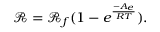Convert formula to latex. <formula><loc_0><loc_0><loc_500><loc_500>\mathcal { R } = \mathcal { R } _ { f } ( 1 - e ^ { \frac { - A _ { e } } { R T } } ) .</formula> 